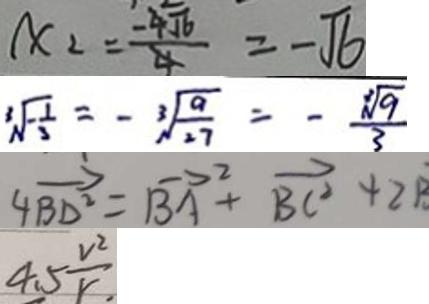<formula> <loc_0><loc_0><loc_500><loc_500>x _ { 2 } = \frac { - \sqrt { 6 } } { 4 } = - \sqrt { 6 } 
 \sqrt [ 3 ] { - \frac { 1 } { 3 } } = - \sqrt [ 3 ] { \frac { 9 } { 2 7 } } = - \frac { \sqrt [ 3 ] { 9 } } { 3 } 
 4 \overrightarrow { B D ^ { 2 } } = \overrightarrow { B A } ^ { 2 } + \overrightarrow { B C ^ { 2 } } + 2 B 
 4 . 5 \frac { v ^ { 2 } } { r . }</formula> 